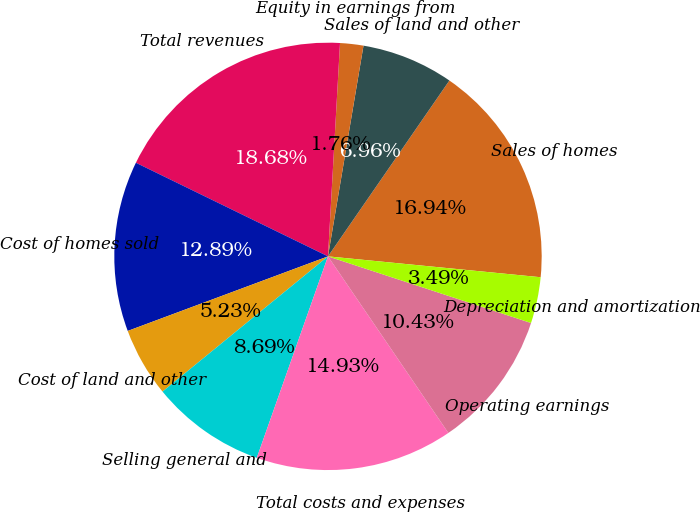Convert chart. <chart><loc_0><loc_0><loc_500><loc_500><pie_chart><fcel>Sales of homes<fcel>Sales of land and other<fcel>Equity in earnings from<fcel>Total revenues<fcel>Cost of homes sold<fcel>Cost of land and other<fcel>Selling general and<fcel>Total costs and expenses<fcel>Operating earnings<fcel>Depreciation and amortization<nl><fcel>16.94%<fcel>6.96%<fcel>1.76%<fcel>18.68%<fcel>12.89%<fcel>5.23%<fcel>8.69%<fcel>14.93%<fcel>10.43%<fcel>3.49%<nl></chart> 